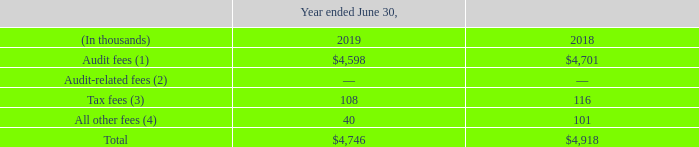Item 14. Principal Accountant Fees and Services
The aggregate fees for professional services rendered by our independent registered public accounting firm, KPMG LLP, for Fiscal 2019 and Fiscal 2018 were:
(1) Audit fees were primarily for professional services rendered for (a) the annual audits of our consolidated financial statements and the accompanying attestation report regarding our ICFR contained in our Annual Report on Form 10- K, (b) the review of quarterly financial information included in our Quarterly Reports on Form 10-Q, (c) audit services related to mergers and acquisitions and offering documents, and (d) annual statutory audits where applicable.
(2) Audit-related fees were primarily for assurance and related services, such as the review of non-periodic filings with the SEC.
(3) Tax fees were for services related to tax compliance, including the preparation of tax returns, tax planning and tax advice.
(4) All other fees consist of fees for services other than the services reported in audit fees, audit-related fees, and tax fees.
OpenText's Audit Committee has established a policy of reviewing, in advance, and either approving or not approving, all audit, audit-related, tax and other non-audit services that our independent registered public accounting firm provides to us. This policy requires that all services received from our independent registered public accounting firm be approved in advance by the Audit Committee or a delegate of the Audit Committee. The Audit Committee has delegated the pre-approval responsibility to the Chair of the Audit Committee. All services that KPMG LLP provided to us in Fiscal 2019 and Fiscal 2018 have been preapproved by the Audit Committee.
The Audit Committee has determined that the provision of the services as set out above is compatible with the maintaining of KPMG LLP's independence in the conduct of its auditing functions.
What company renders the professional service to Open Text Corporation Kpmg llp. What years did KPMG LLP provide service to the company that was preapproved by the Audit Committee? Fiscal 2019 and fiscal 2018. What units does the table use? Thousands. In year ended 2019, what is the Audit fees expressed as a percentage of total fees?
Answer scale should be: percent. 4,598/4,746
Answer: 96.88. What is the average annual total Fees for Fiscal year 2019 and 2018?
Answer scale should be: thousand. (4,746+4,918)/2
Answer: 4832. What is the Tax fees for fiscal year 2019 expressed as a percentage of total fees?
Answer scale should be: percent. 108/4,746
Answer: 2.28. 